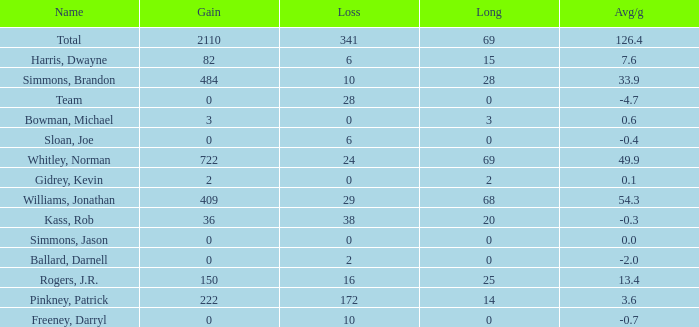What is the lowest Long, when Name is Kass, Rob, and when Avg/g is less than -0.30000000000000004? None. 